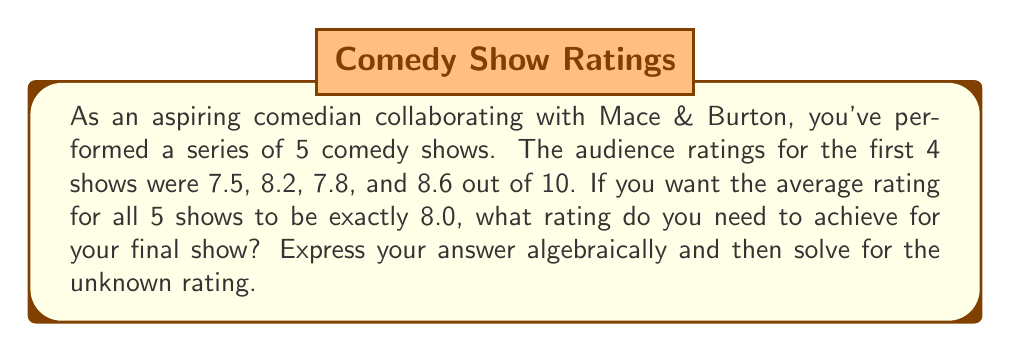Teach me how to tackle this problem. Let's approach this step-by-step:

1) First, let's define our variable:
   Let $x$ = the rating of the final show

2) We know that the average of all 5 shows should be 8.0. In algebraic terms:

   $\frac{7.5 + 8.2 + 7.8 + 8.6 + x}{5} = 8.0$

3) To solve this, let's multiply both sides by 5:

   $7.5 + 8.2 + 7.8 + 8.6 + x = 8.0 \cdot 5 = 40$

4) Now, let's add up the known ratings:

   $7.5 + 8.2 + 7.8 + 8.6 = 32.1$

5) Substituting this back into our equation:

   $32.1 + x = 40$

6) Subtract 32.1 from both sides:

   $x = 40 - 32.1 = 7.9$

Therefore, to achieve an average rating of 8.0 for all 5 shows, you need to get a rating of 7.9 for your final show.

To verify:
$\frac{7.5 + 8.2 + 7.8 + 8.6 + 7.9}{5} = \frac{40}{5} = 8.0$
Answer: The required rating for the final show is 7.9. 